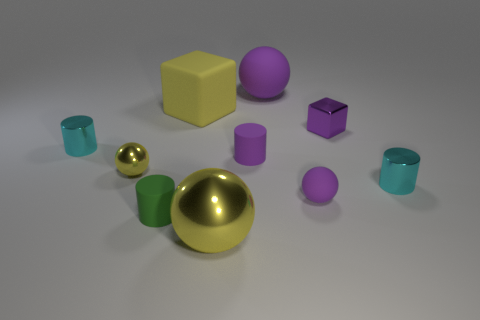The other matte object that is the same shape as the small green thing is what color?
Your response must be concise. Purple. Are there any other things that have the same material as the yellow block?
Your answer should be compact. Yes. What number of purple objects are either small rubber cylinders or cubes?
Make the answer very short. 2. How many tiny objects are in front of the small purple sphere and to the right of the small purple sphere?
Offer a very short reply. 0. There is a small purple thing that is on the left side of the purple object in front of the cyan metallic cylinder that is right of the purple matte cylinder; what is it made of?
Offer a very short reply. Rubber. What number of large things have the same material as the tiny yellow sphere?
Provide a short and direct response. 1. The large shiny thing that is the same color as the matte cube is what shape?
Offer a very short reply. Sphere. There is a green thing that is the same size as the purple cube; what shape is it?
Your response must be concise. Cylinder. There is a large ball that is the same color as the rubber block; what is its material?
Keep it short and to the point. Metal. Are there any tiny green matte things to the left of the big metal sphere?
Keep it short and to the point. Yes. 